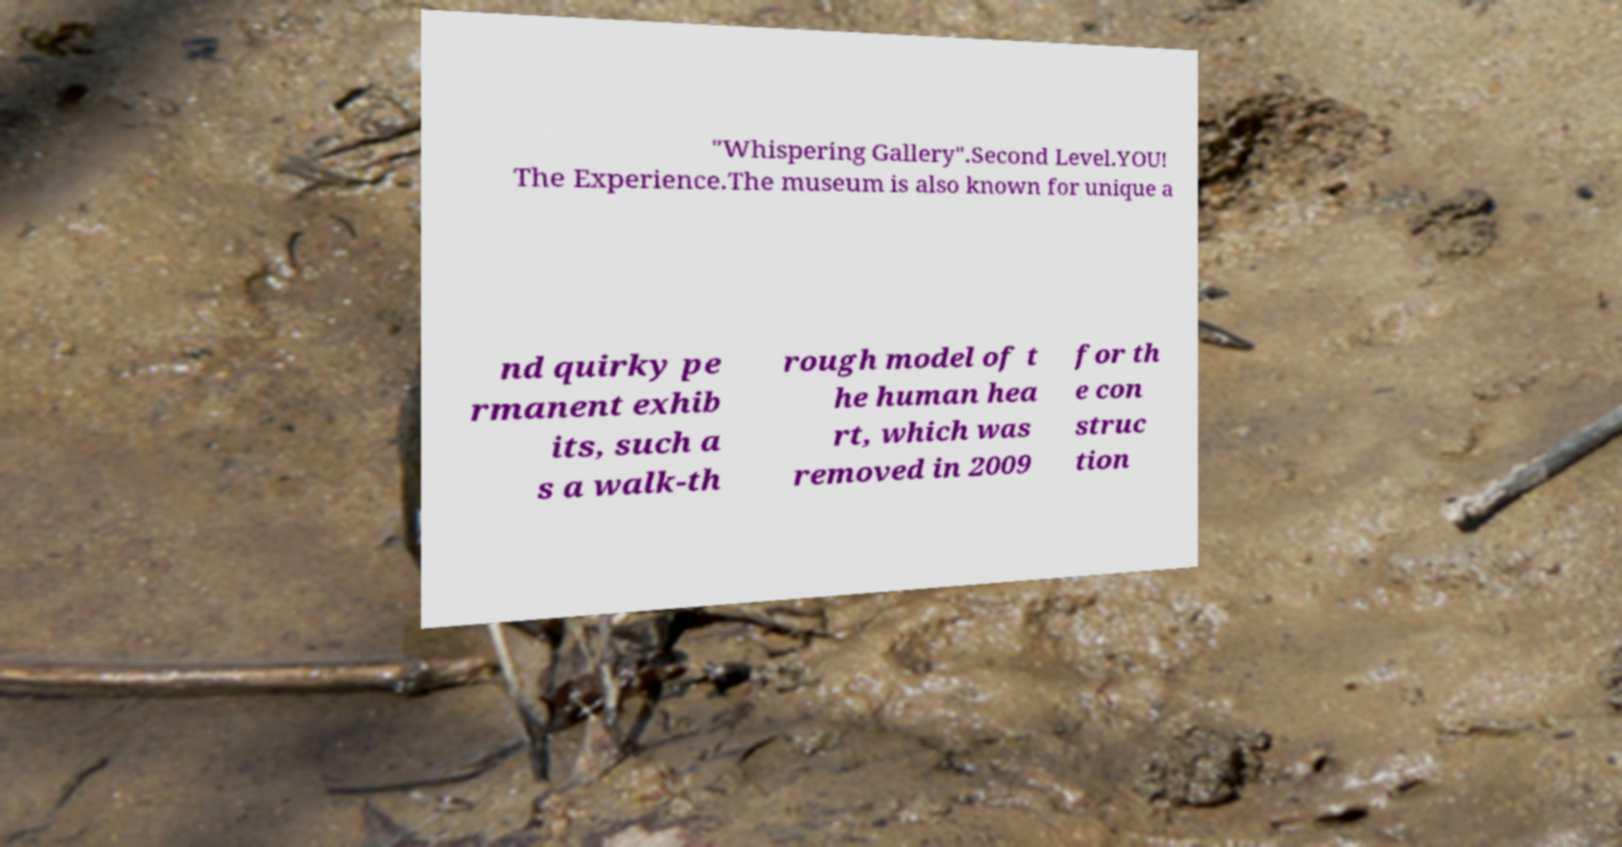Can you accurately transcribe the text from the provided image for me? "Whispering Gallery".Second Level.YOU! The Experience.The museum is also known for unique a nd quirky pe rmanent exhib its, such a s a walk-th rough model of t he human hea rt, which was removed in 2009 for th e con struc tion 